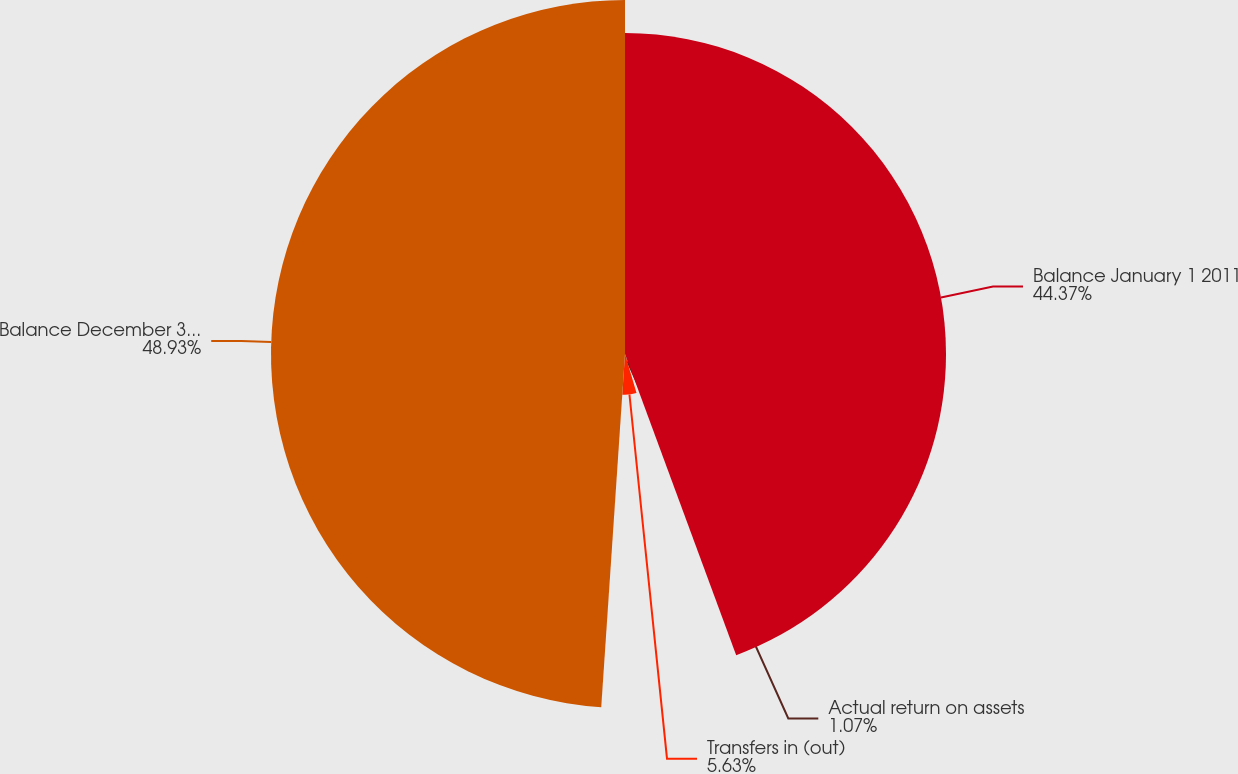<chart> <loc_0><loc_0><loc_500><loc_500><pie_chart><fcel>Balance January 1 2011<fcel>Actual return on assets<fcel>Transfers in (out)<fcel>Balance December 31 2011<nl><fcel>44.37%<fcel>1.07%<fcel>5.63%<fcel>48.93%<nl></chart> 